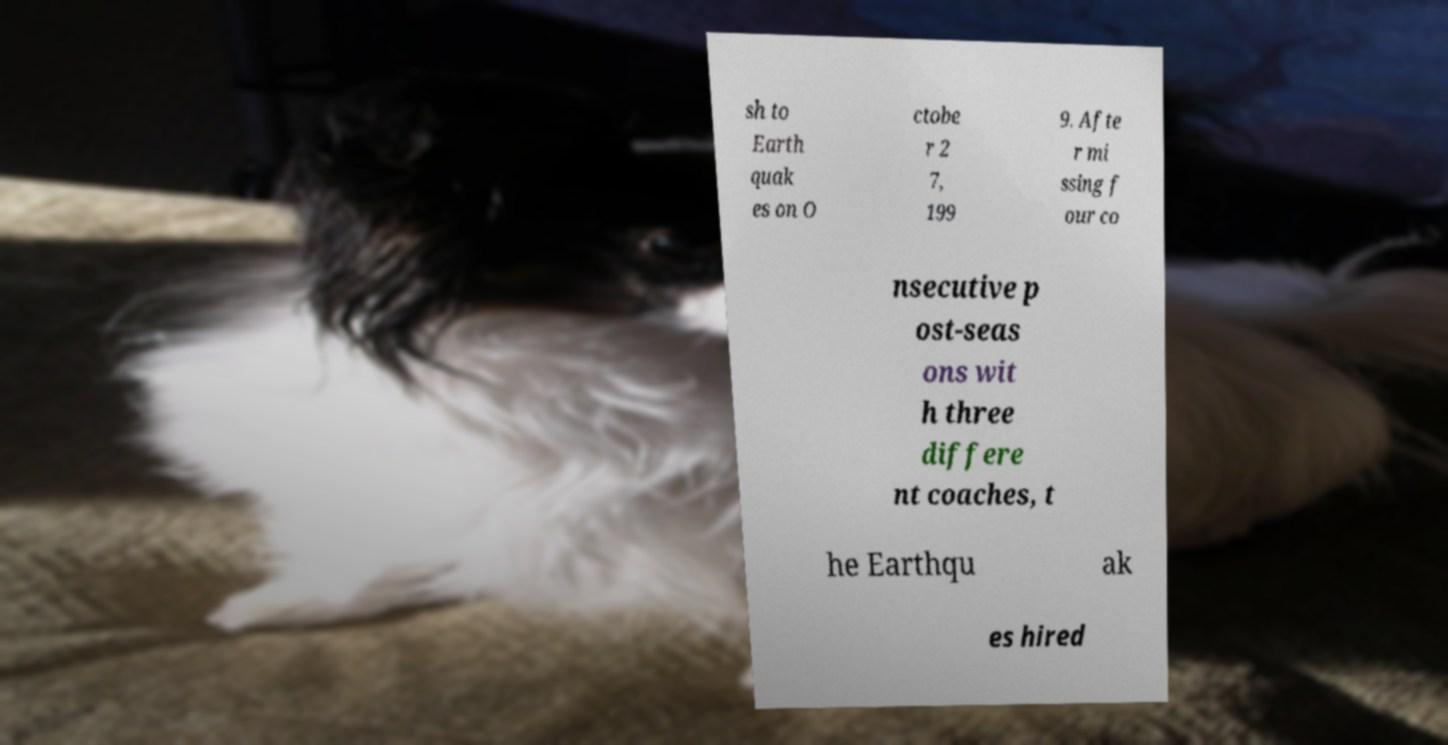Can you read and provide the text displayed in the image?This photo seems to have some interesting text. Can you extract and type it out for me? sh to Earth quak es on O ctobe r 2 7, 199 9. Afte r mi ssing f our co nsecutive p ost-seas ons wit h three differe nt coaches, t he Earthqu ak es hired 